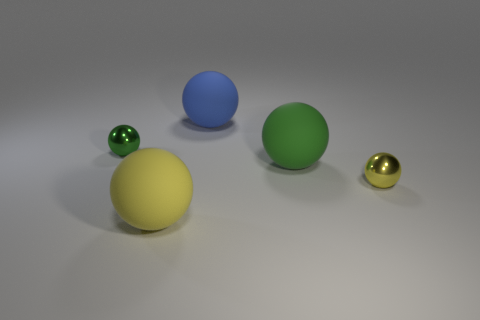Subtract all big green spheres. How many spheres are left? 4 Subtract all yellow blocks. How many yellow balls are left? 2 Subtract all blue spheres. How many spheres are left? 4 Subtract all gray balls. Subtract all yellow cylinders. How many balls are left? 5 Add 1 small yellow objects. How many objects exist? 6 Subtract 0 brown cylinders. How many objects are left? 5 Subtract all yellow objects. Subtract all large blue matte balls. How many objects are left? 2 Add 3 large matte balls. How many large matte balls are left? 6 Add 5 big matte things. How many big matte things exist? 8 